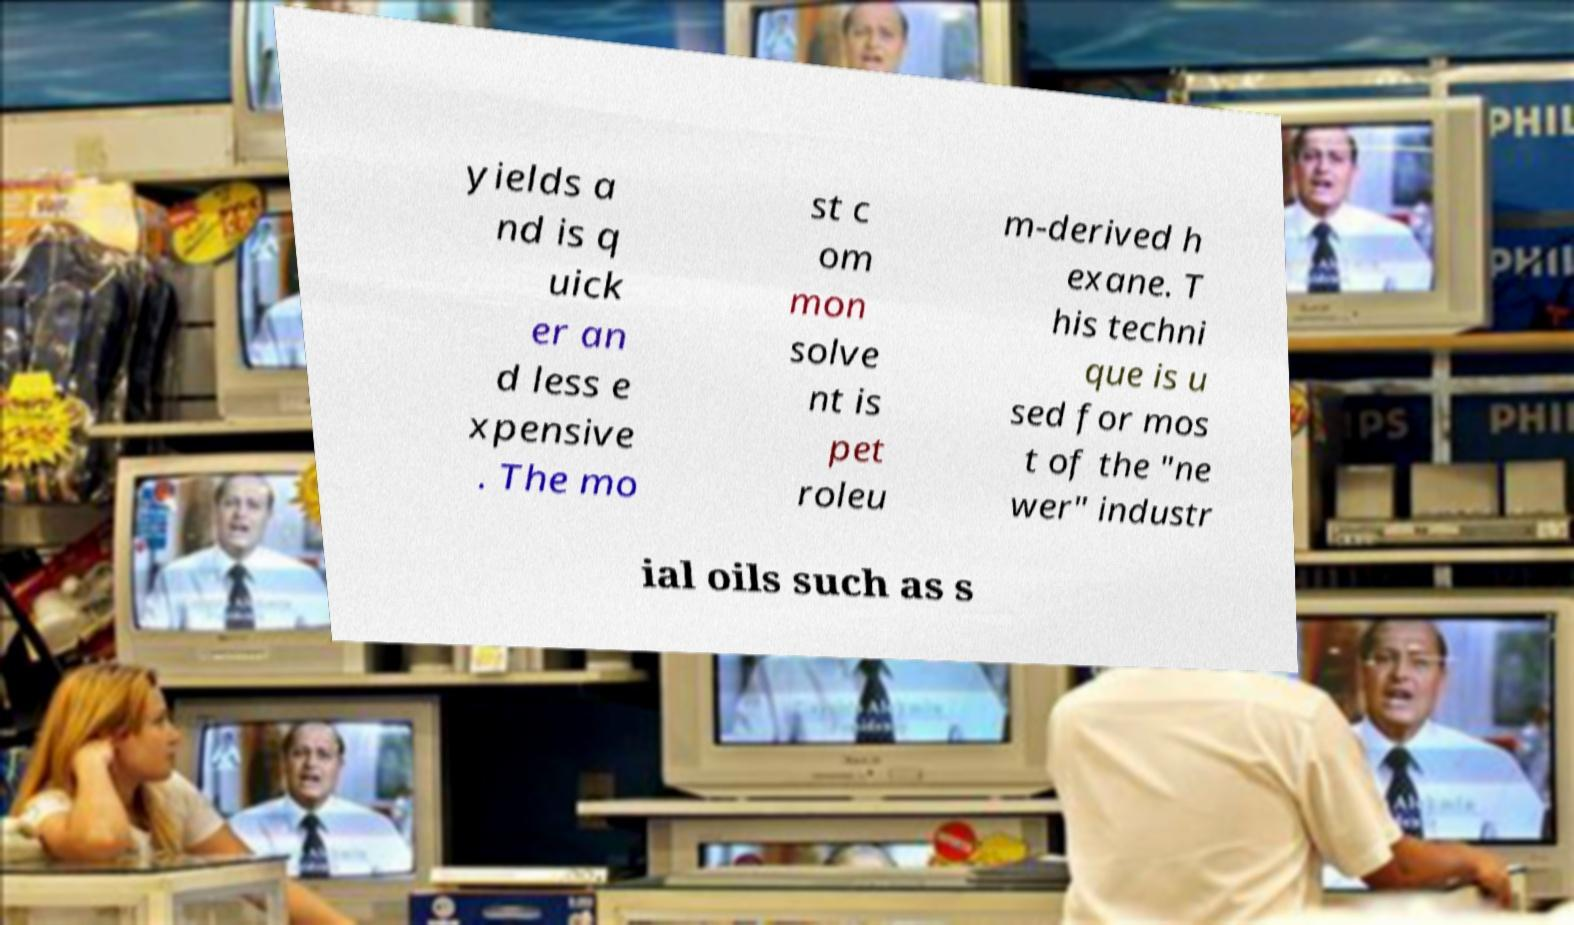Please identify and transcribe the text found in this image. yields a nd is q uick er an d less e xpensive . The mo st c om mon solve nt is pet roleu m-derived h exane. T his techni que is u sed for mos t of the "ne wer" industr ial oils such as s 